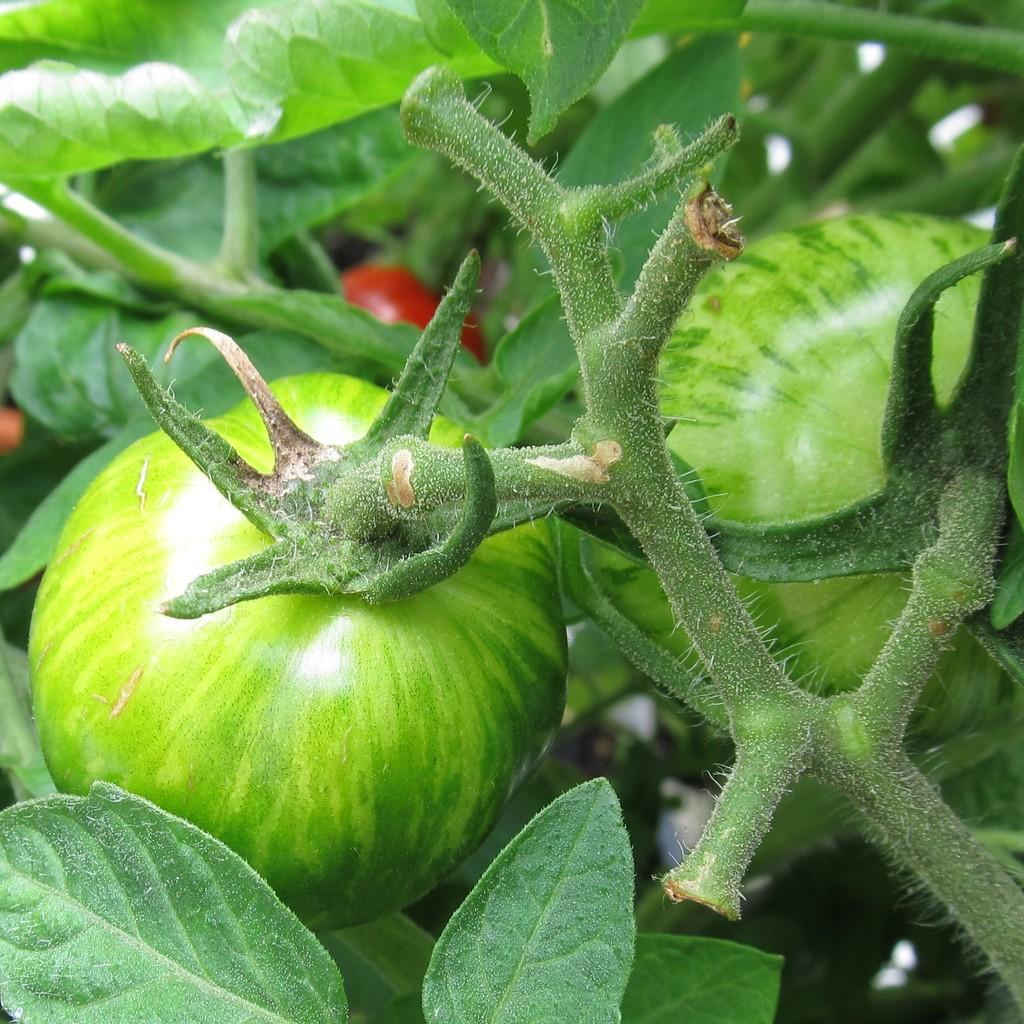How would you summarize this image in a sentence or two? In this image I can see fruits and stem of plants and leaves 